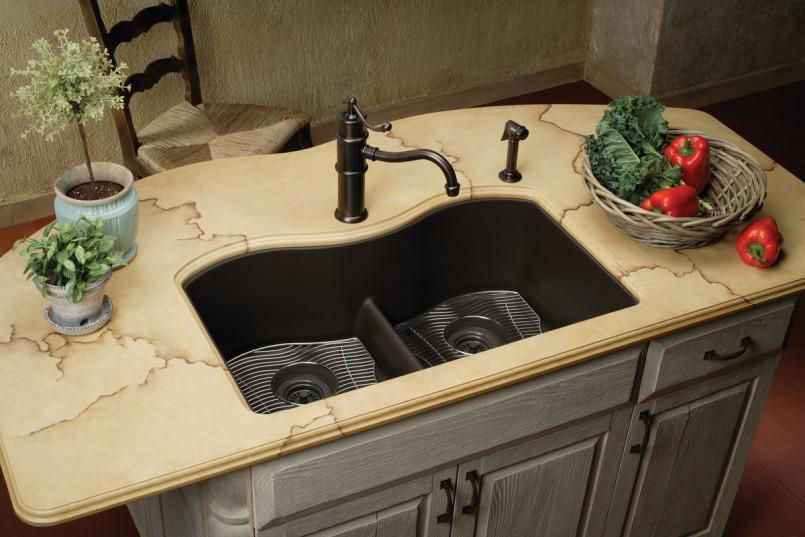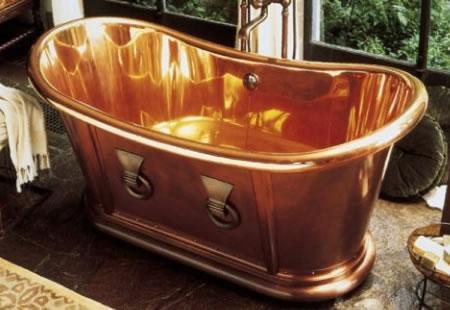The first image is the image on the left, the second image is the image on the right. Considering the images on both sides, is "Water is running from a faucet in one of the images." valid? Answer yes or no. No. The first image is the image on the left, the second image is the image on the right. Given the left and right images, does the statement "Water is coming out of one of the faucets." hold true? Answer yes or no. No. 